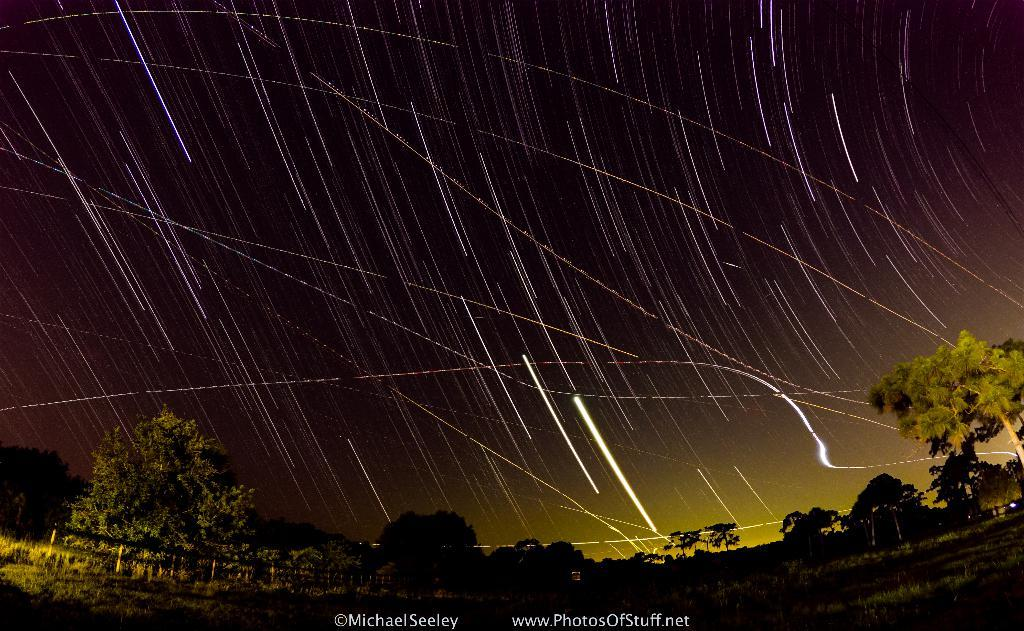What type of vegetation is at the bottom of the image? There are trees at the bottom of the image. What text can be seen in the image? There is a watermark text in the image. What part of the natural environment is visible in the image? The sky is visible at the top of the image. Has the image been altered in any way? Yes, the image has been edited. How many pieces of furniture are visible in the image? There are no pieces of furniture present in the image. What type of pipe can be seen in the image? There is no pipe present in the image. 